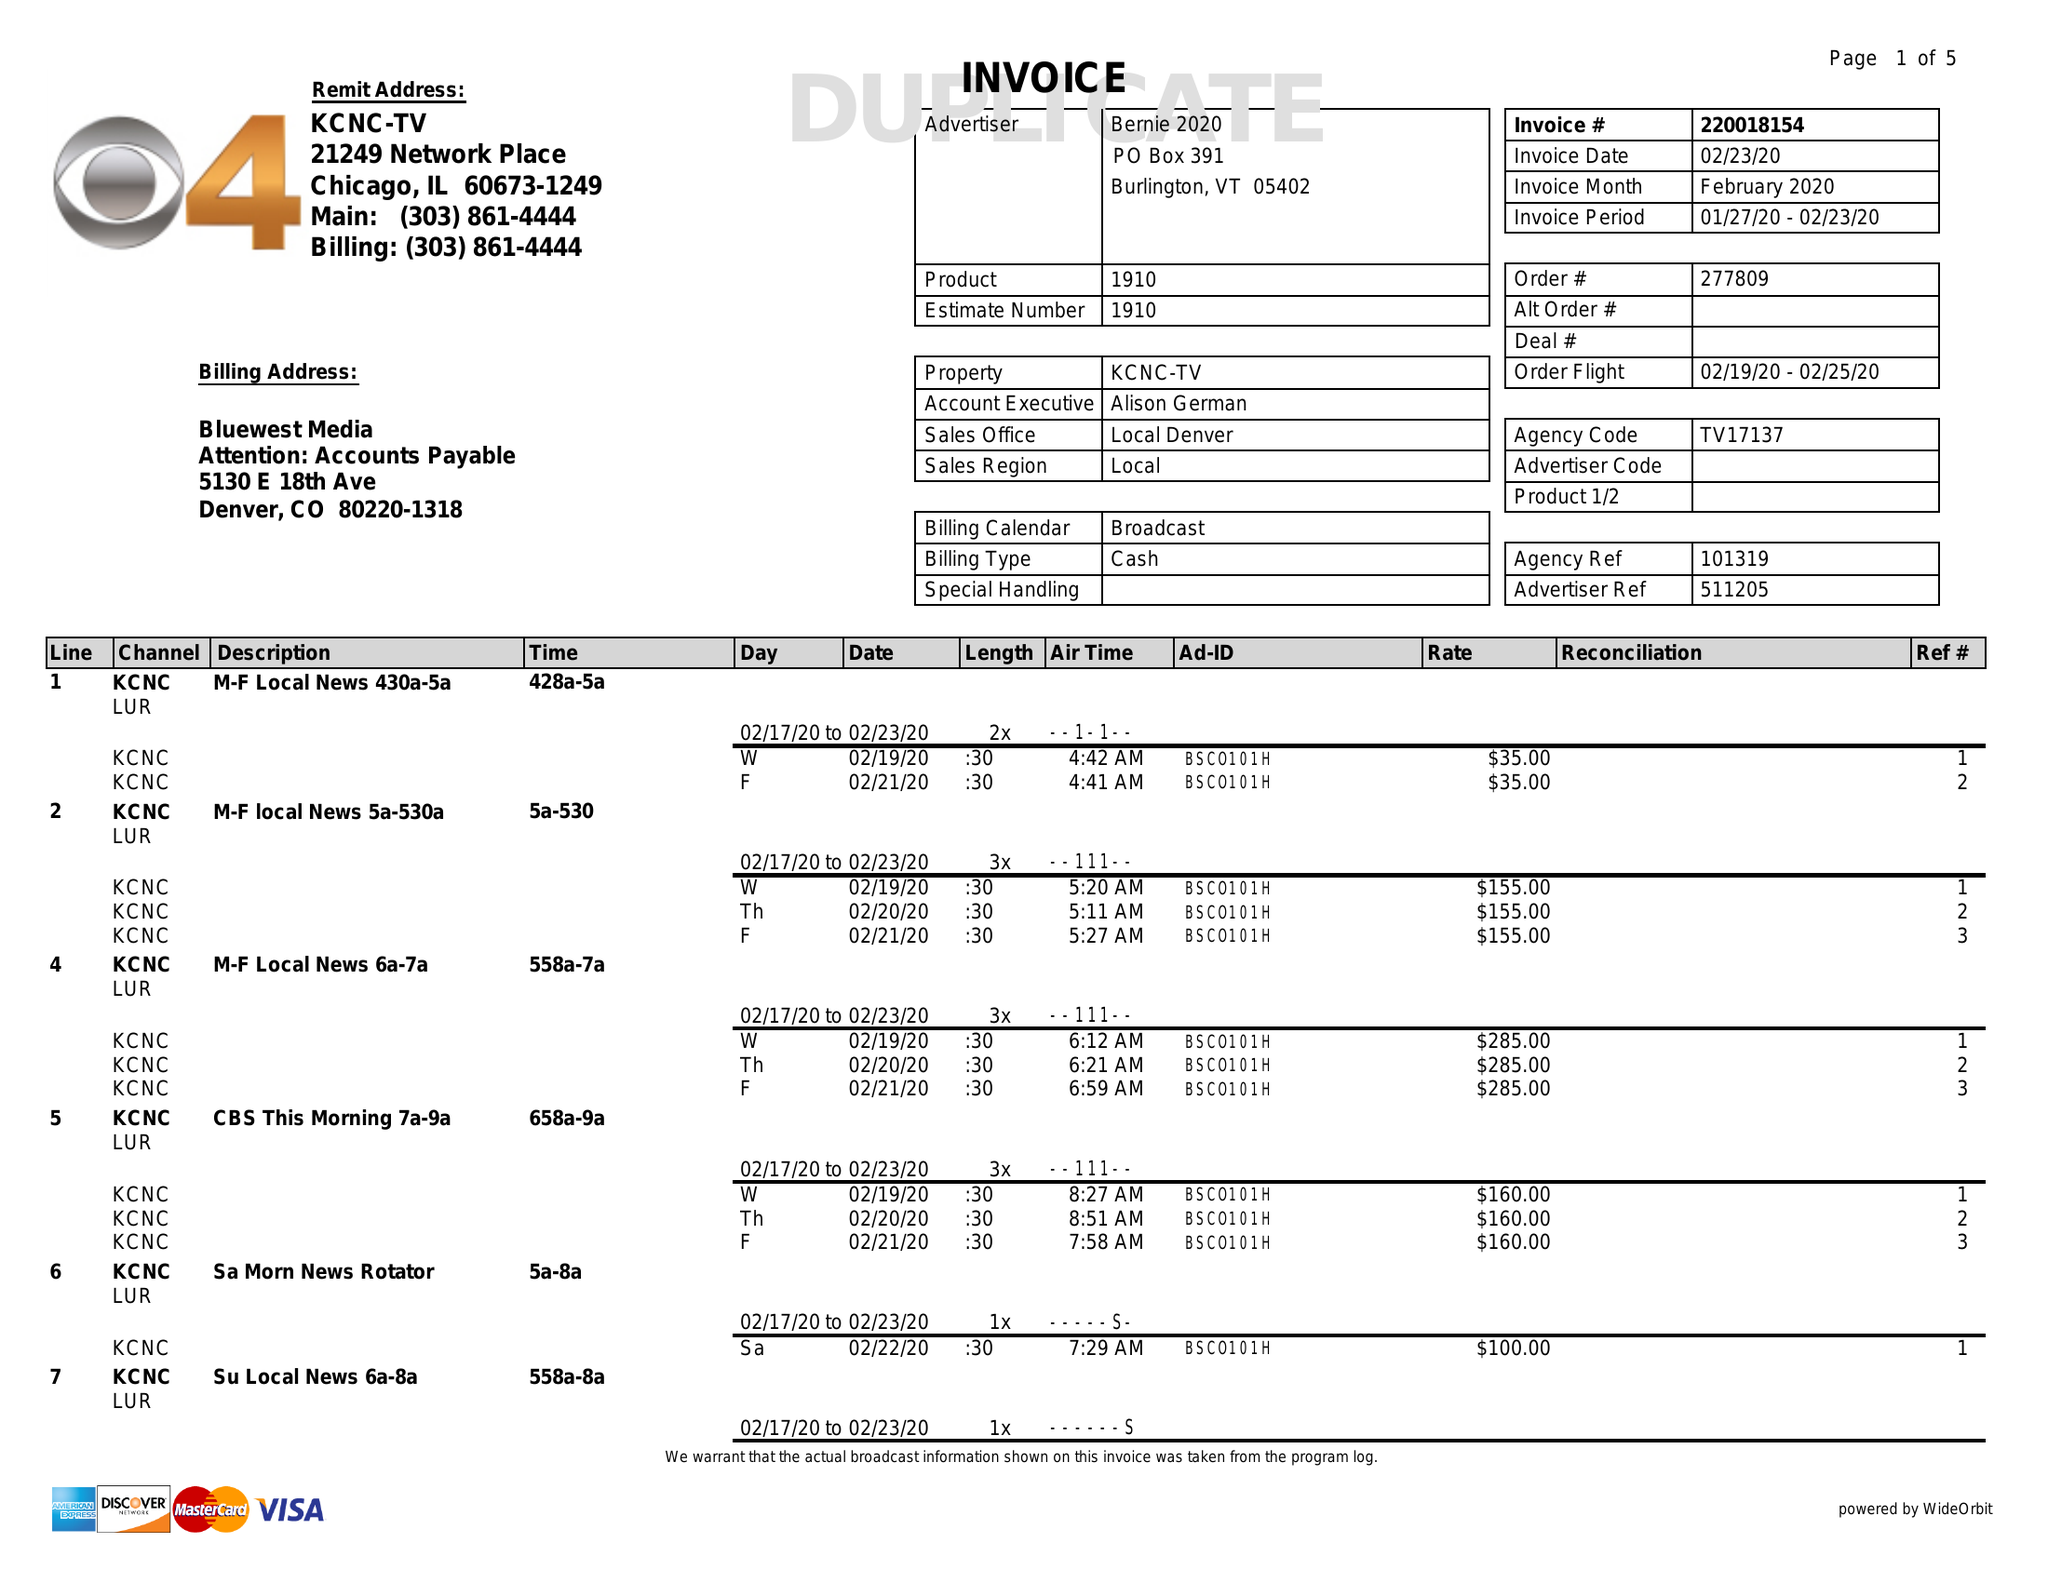What is the value for the contract_num?
Answer the question using a single word or phrase. 220018154 